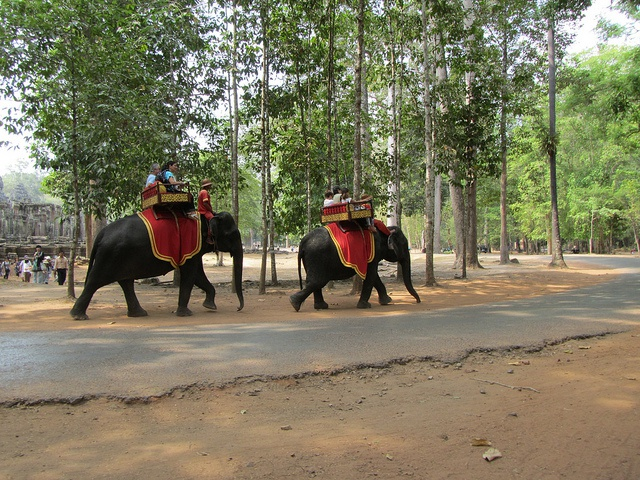Describe the objects in this image and their specific colors. I can see elephant in lightgreen, black, gray, and darkgreen tones, elephant in lightgreen, black, and gray tones, bench in lightgreen, black, olive, and maroon tones, bench in lightgreen, black, olive, and maroon tones, and people in lightgreen, black, gray, and maroon tones in this image. 